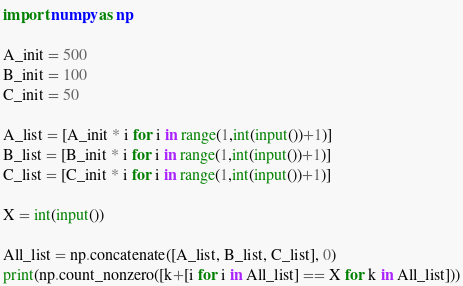Convert code to text. <code><loc_0><loc_0><loc_500><loc_500><_Python_>import numpy as np

A_init = 500
B_init = 100
C_init = 50

A_list = [A_init * i for i in range(1,int(input())+1)]
B_list = [B_init * i for i in range(1,int(input())+1)]
C_list = [C_init * i for i in range(1,int(input())+1)]

X = int(input())

All_list = np.concatenate([A_list, B_list, C_list], 0)
print(np.count_nonzero([k+[i for i in All_list] == X for k in All_list]))</code> 